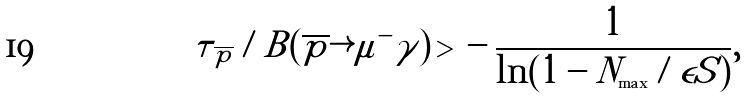<formula> <loc_0><loc_0><loc_500><loc_500>\tau _ { \, \overline { p } } / B ( \overline { p } \rightarrow \mu ^ { - } \gamma ) \, > \, - \, \frac { 1 } { \ln ( 1 - N _ { \max } / \epsilon S ) } ,</formula> 